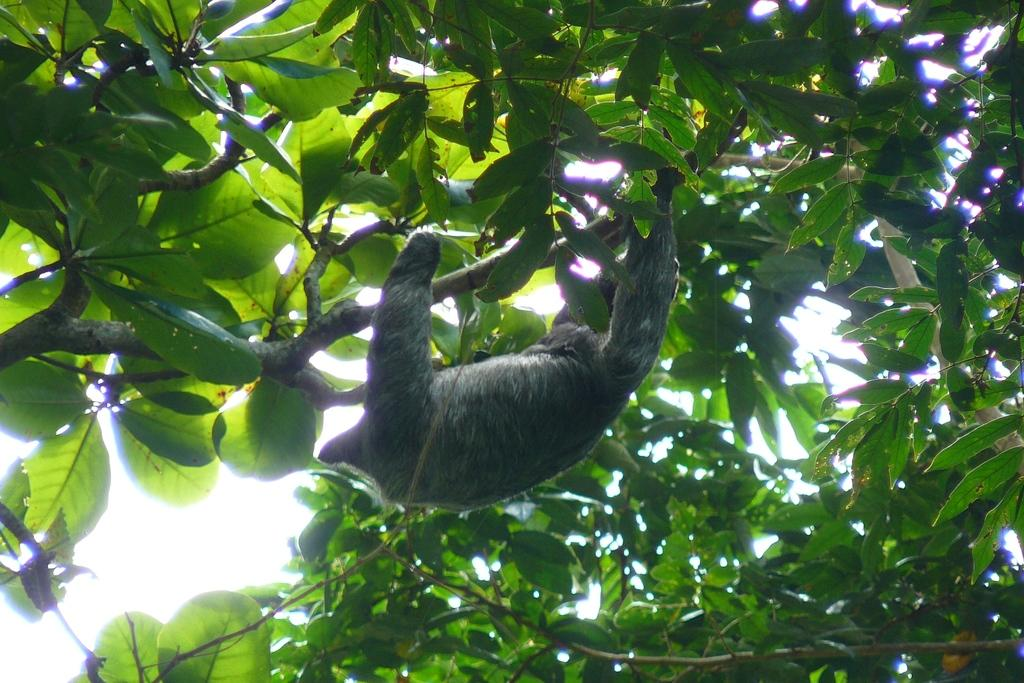What type of living creature is present in the image? There is an animal in the image. What can be seen in the background of the image? There are trees in the image. What type of tray is being used to catch the current in the image? There is no tray or current present in the image; it features an animal and trees. 